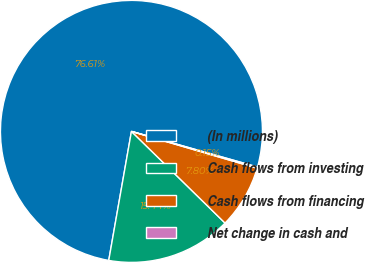Convert chart to OTSL. <chart><loc_0><loc_0><loc_500><loc_500><pie_chart><fcel>(In millions)<fcel>Cash flows from investing<fcel>Cash flows from financing<fcel>Net change in cash and<nl><fcel>76.61%<fcel>15.44%<fcel>7.8%<fcel>0.15%<nl></chart> 